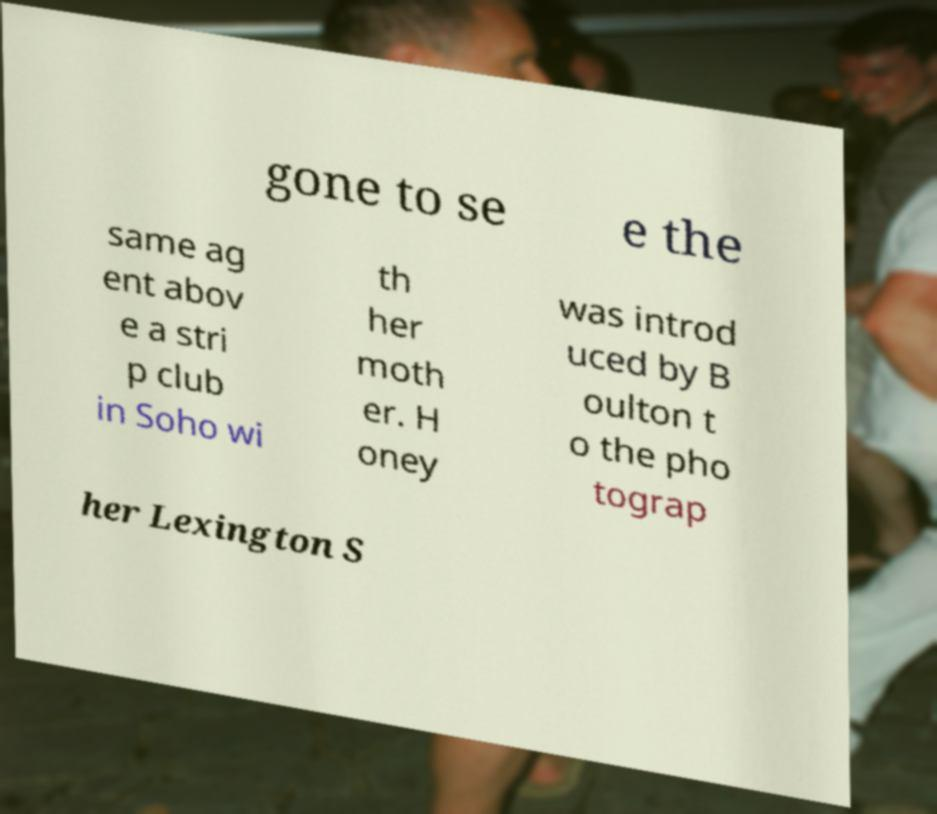Could you assist in decoding the text presented in this image and type it out clearly? gone to se e the same ag ent abov e a stri p club in Soho wi th her moth er. H oney was introd uced by B oulton t o the pho tograp her Lexington S 